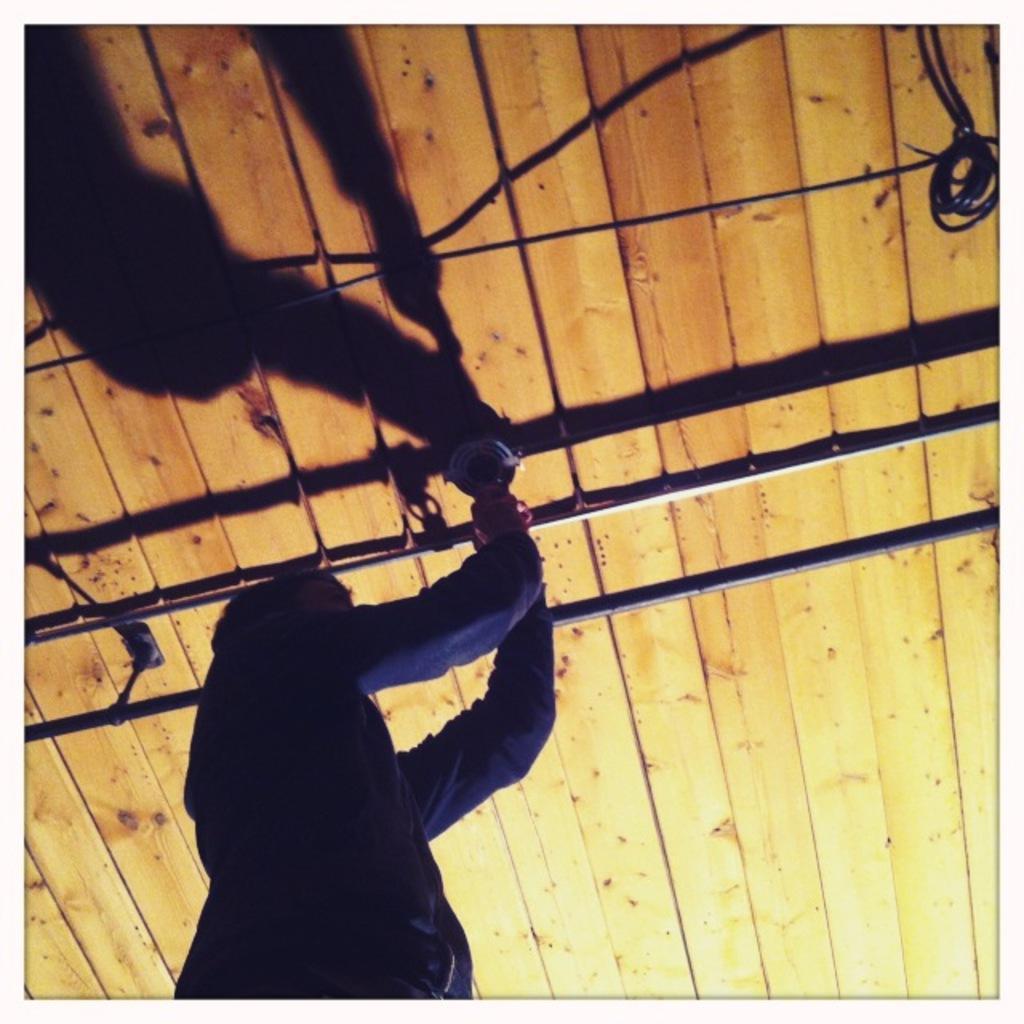Please provide a concise description of this image. In the image we can see a person wearing clothes and holding an object in hand. These are the pipes, cable wire and wooden sheets. 